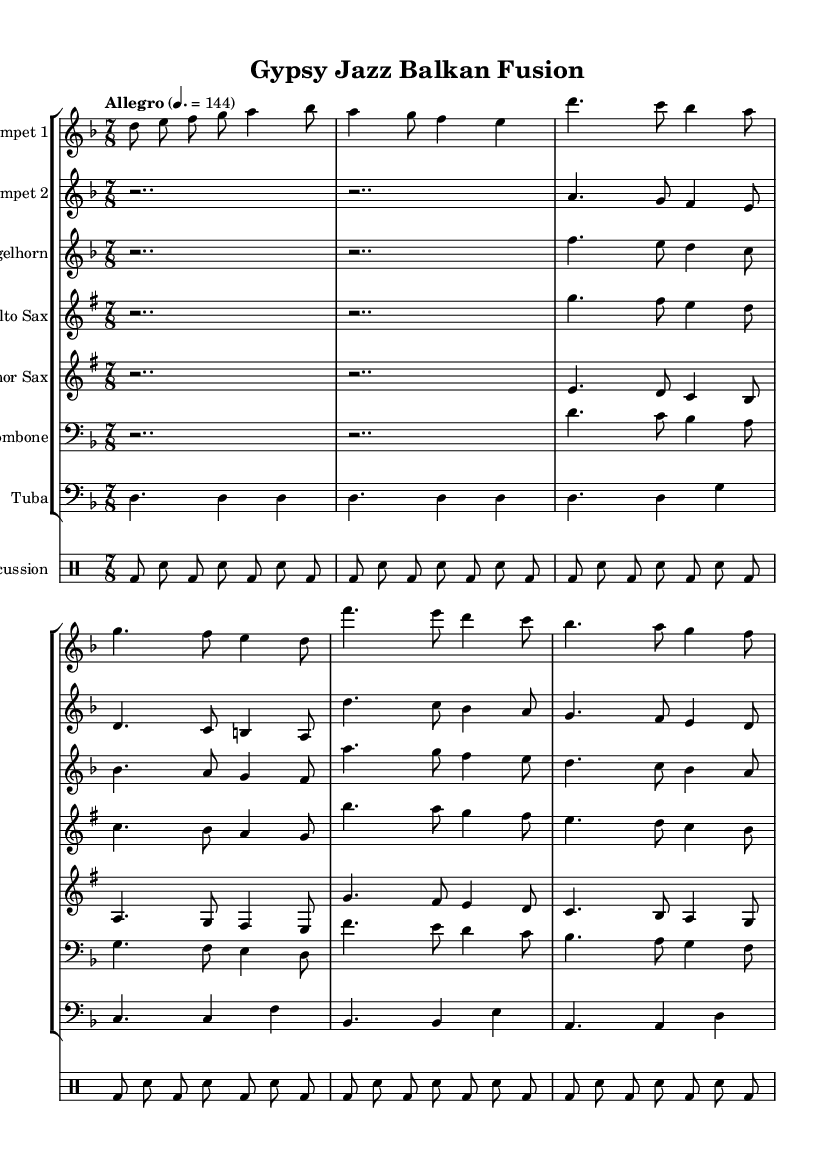What is the key signature of this music? The key signature is D minor, which is indicated by one flat (B flat) in the music notation.
Answer: D minor What is the time signature of this music? The time signature is 7/8, indicated at the beginning of the score, which shows there are 7 eighth notes per measure, creating a compound meter feel.
Answer: 7/8 What is the tempo marking for this piece? The tempo marking is "Allegro," which is specified in the score along with a metronome marking of 144 quarter notes per minute, indicating a lively and fast pace for the performance.
Answer: Allegro How many distinct sections are indicated in the music? There are two distinct sections labeled A and B, each with different melodic material that contributes to the overall structure of the piece.
Answer: Two Which instruments are featured in this composition? The composition features Trumpet 1, Trumpet 2, Flugelhorn, Alto Sax, Tenor Sax, Trombone, Tuba, and Percussion, as indicated by their respective staves in the score.
Answer: Trumpet 1, Trumpet 2, Flugelhorn, Alto Sax, Tenor Sax, Trombone, Tuba, Percussion What rhythmic pattern does the percussion section utilize? The percussion section uses a 3+2+2 pattern throughout the piece, which is evident from the repeated kick drum and snare drum notations that create a vivid groove characteristic of Balkan music.
Answer: 3+2+2 pattern Which musical styles are fused in this composition? The composition fuses Romani and jazz influences, evident from the use of improvisational elements typical of jazz and the lively, syncopated rhythms that are characteristic of Romani music.
Answer: Romani and Jazz 